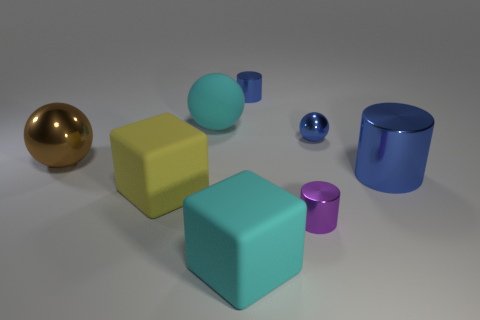There is a cylinder that is both behind the yellow thing and to the left of the large blue metallic cylinder; what is it made of?
Make the answer very short. Metal. There is a tiny metal cylinder that is behind the large yellow matte cube; are there any big cyan rubber blocks that are to the right of it?
Offer a very short reply. No. What number of blocks are the same color as the big rubber ball?
Make the answer very short. 1. What is the material of the tiny cylinder that is the same color as the tiny ball?
Make the answer very short. Metal. Is the big cyan block made of the same material as the big yellow thing?
Your answer should be compact. Yes. Are there any big metallic cylinders in front of the big blue cylinder?
Your answer should be compact. No. There is a cyan object right of the big ball on the right side of the large brown object; what is its material?
Offer a terse response. Rubber. There is another metallic thing that is the same shape as the big brown metal thing; what size is it?
Offer a very short reply. Small. Is the color of the large cylinder the same as the tiny metal sphere?
Your answer should be compact. Yes. There is a large thing that is in front of the big blue shiny cylinder and on the left side of the matte ball; what color is it?
Your response must be concise. Yellow. 